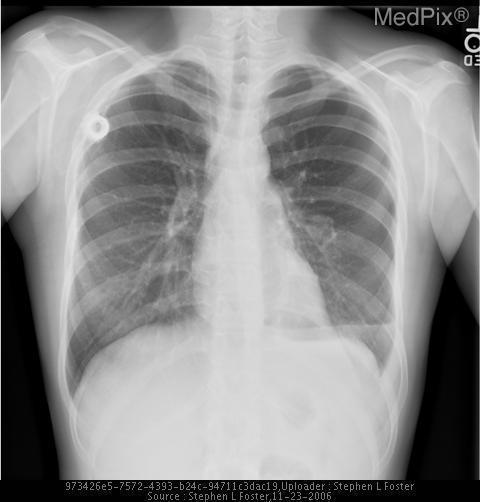Is there a pneumothorax?
Concise answer only. Yes. Do you see a pleural effusion?
Short answer required. No. Is there a pleural effusion present?
Keep it brief. No. How was this film taken?
Quick response, please. Pa. Do you see cardiomegaly?
Be succinct. No. Is cardiomegaly present?
Answer briefly. No. Is this a kub film?
Concise answer only. No. Is this a plain film xray?
Quick response, please. Yes. 